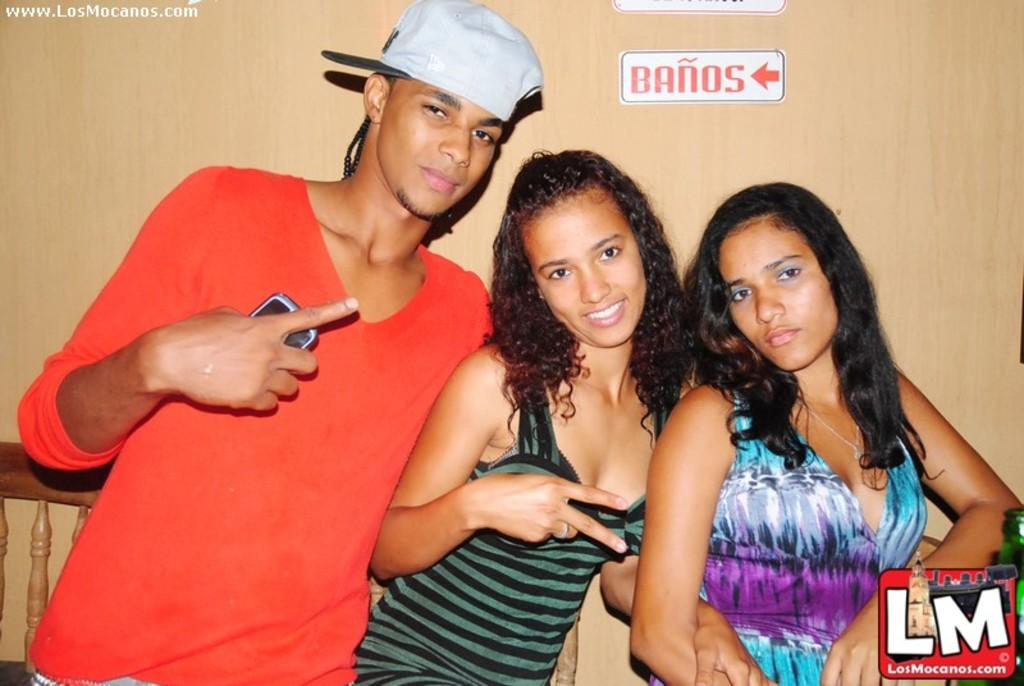How many people are in the image? There are three people standing in the image. What is the person on the left wearing? The person on the left is wearing a red t-shirt and a cap. What can be seen in the background of the image? There is a wooden railing and a wall in the image. What type of sponge is the person on the right holding in the image? There is no sponge present in the image. Can you describe the face of the person in the middle? The facts provided do not mention any details about the faces of the people in the image, so we cannot describe the face of the person in the middle. 